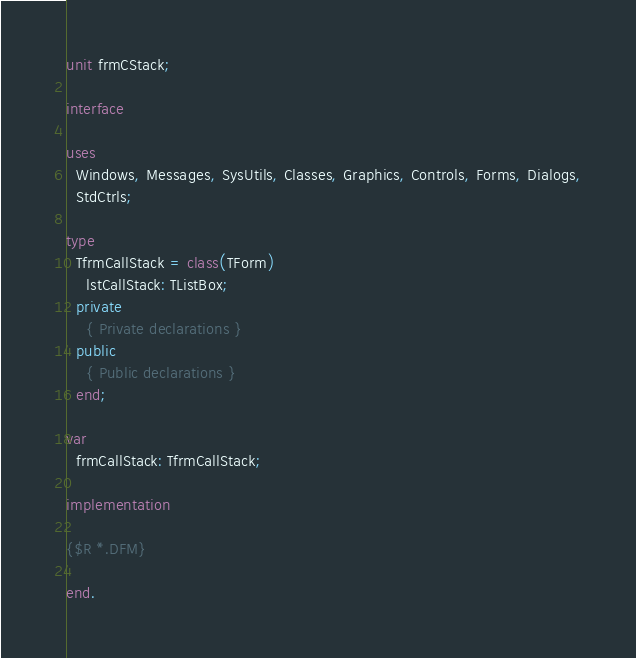<code> <loc_0><loc_0><loc_500><loc_500><_Pascal_>unit frmCStack;

interface

uses
  Windows, Messages, SysUtils, Classes, Graphics, Controls, Forms, Dialogs,
  StdCtrls;

type
  TfrmCallStack = class(TForm)
    lstCallStack: TListBox;
  private
    { Private declarations }
  public
    { Public declarations }
  end;

var
  frmCallStack: TfrmCallStack;

implementation

{$R *.DFM}

end.
</code> 